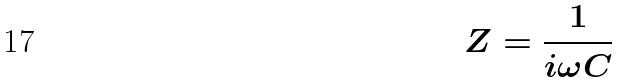<formula> <loc_0><loc_0><loc_500><loc_500>Z = \frac { 1 } { i \omega C }</formula> 